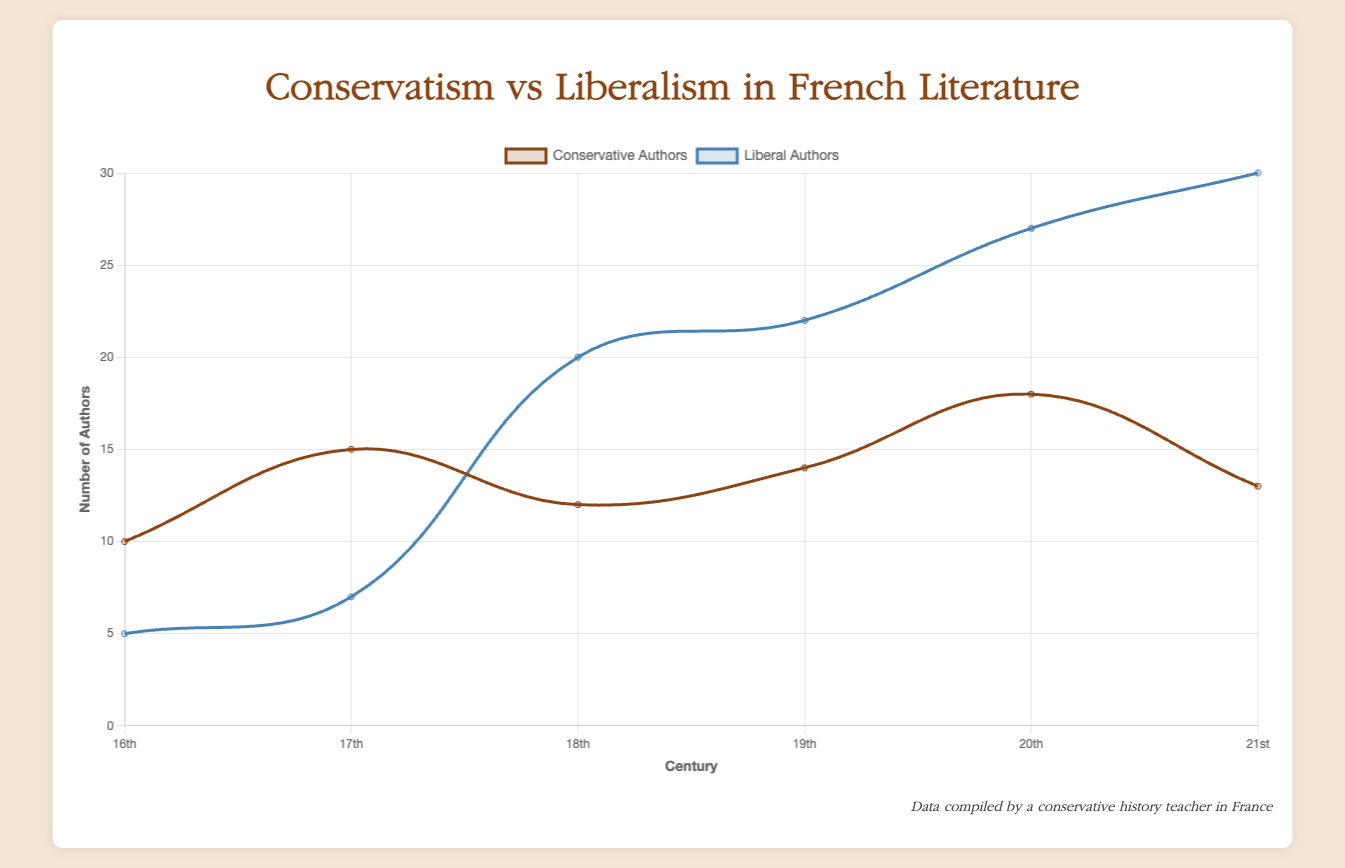What is the total number of conservative authors in the 17th and 18th centuries combined? The number of conservative authors in the 17th century is 15, and in the 18th century it is 12. Summing these values, 15 + 12 = 27
Answer: 27 Comparing the 16th and 21st centuries, in which century were there more liberal authors? There were 5 liberal authors in the 16th century and 30 liberal authors in the 21st century. 30 is greater than 5
Answer: 21st century How much higher is the number of liberal authors than conservative authors in the 20th century? In the 20th century, there were 27 liberal authors and 18 conservative authors. The difference is 27 - 18 = 9
Answer: 9 In which century did conservative authors outnumber liberal authors the most? By visually comparing the difference between conservative and liberal authors across centuries, the 16th century has the greatest difference favoring conservative authors: 10 - 5 = 5
Answer: 16th century Which century shows the smallest gap between the number of conservative and liberal authors? The gap can be calculated as the absolute difference between conservative and liberal authors for each century. The smallest gap is in the 17th century, with 15 conservative and 7 liberal authors:
Answer: 17th century Which dataset has a steeper rise in the number of authors from the 19th to the 20th century? The number of conservative authors rises from 14 to 18 (an increase of 4), while the number of liberal authors rises from 22 to 27 (an increase of 5). The liberal authors have a steeper rise
Answer: Liberal Authors What is the visual difference in the number of authors in the 20th and 21st centuries for both conservative and liberal parties? The graph shows that the 20th century has 18 conservative and 27 liberal authors. For the 21st century, there are 13 conservative and 30 liberal authors. Conservatives decrease by 5 (18 - 13), and liberals increase by 3 (30 - 27)
Answer: Conservative: decrease by 5, Liberal: increase by 3 Examining the 19th century, which group shows a higher rate of increase from the previous century? In the 19th century, the number of conservative authors increases from 12 (18th century) to 14, and the number of liberal authors increases from 20 to 22. The rate of increase for conservatives is 14 - 12 = 2, and for liberals it is 22 - 20 = 2. Both groups have the same rate of increase
Answer: Both have the same rate What trend can you observe for liberal authors from the 16th to the 21st century? The number of liberal authors increases steadily from 5 (16th century) to 7 (17th), then to 20 (18th), 22 (19th), 27 (20th), and 30 (21st)
Answer: Increasing trend How does the number of conservative authors in the 21st century compare to the 20th century? The number of conservative authors in the 21st century is 13, down from 18 in the 20th century, showing a decrease
Answer: Decreased 